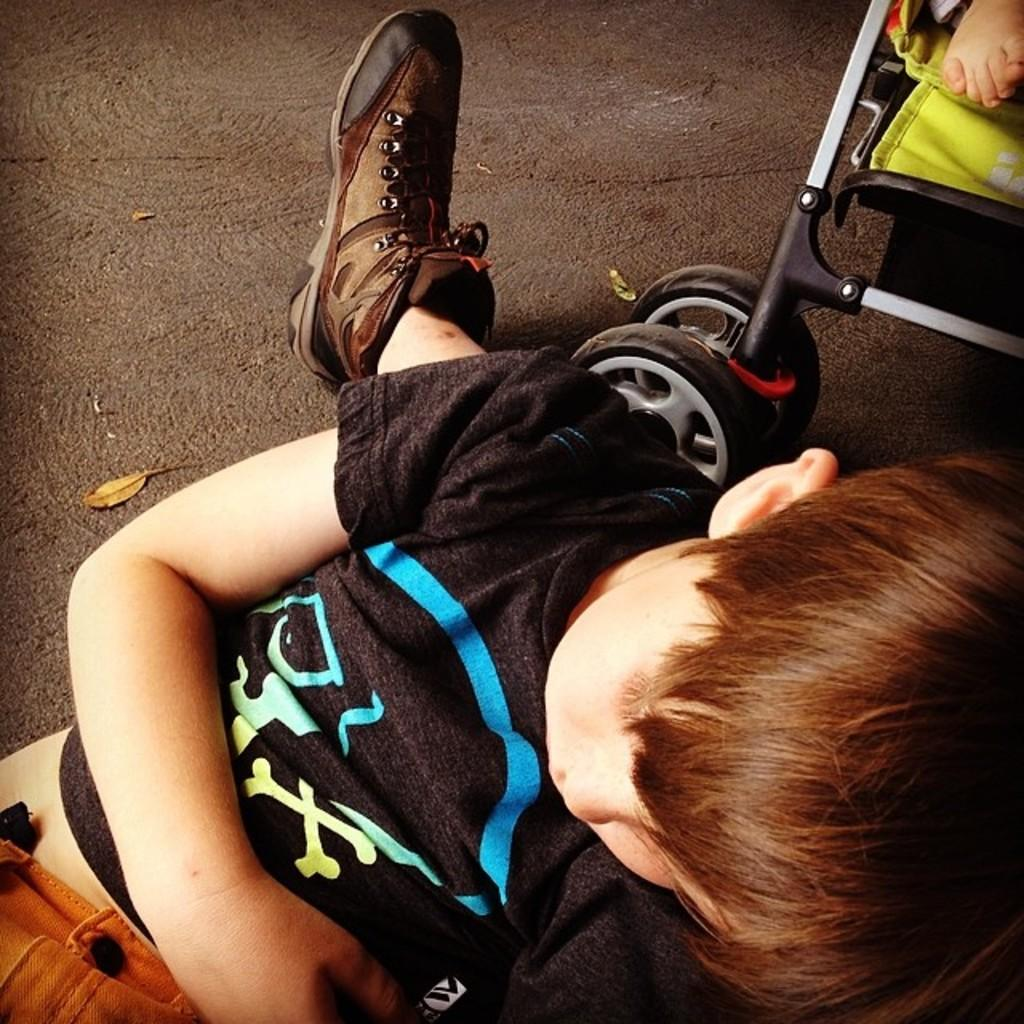Who is the main subject in the image? There is a boy in the image. Can you describe any other elements in the top right corner of the image? A person's leg and a baby trolley are visible in the top right corner of the image. What type of education is being provided in the image? There is no indication of education in the image; it primarily features a boy and a baby trolley in the top right corner. 